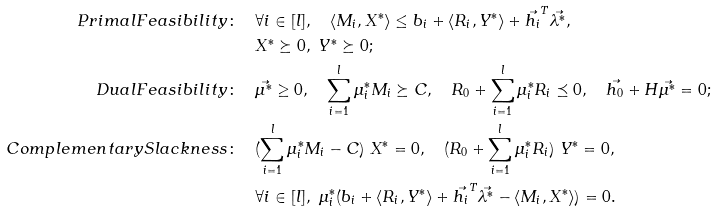<formula> <loc_0><loc_0><loc_500><loc_500>P r i m a l F e a s i b i l i t y \colon & \quad \forall i \in [ l ] , \quad \langle M _ { i } , X ^ { * } \rangle \leq b _ { i } + \langle R _ { i } , Y ^ { * } \rangle + \vec { h _ { i } } ^ { T } \vec { \lambda ^ { * } } , \\ & \quad X ^ { * } \succeq 0 , \ Y ^ { * } \succeq 0 ; \\ D u a l F e a s i b i l i t y \colon & \quad \vec { \mu ^ { * } } \geq 0 , \quad \sum _ { i = 1 } ^ { l } \mu _ { i } ^ { * } M _ { i } \succeq C , \quad R _ { 0 } + \sum _ { i = 1 } ^ { l } \mu _ { i } ^ { * } R _ { i } \preceq 0 , \quad \vec { h _ { 0 } } + H \vec { \mu ^ { * } } = 0 ; \\ C o m p l e m e n t a r y S l a c k n e s s \colon & \quad ( \sum _ { i = 1 } ^ { l } \mu _ { i } ^ { * } M _ { i } - C ) \ X ^ { * } = 0 , \quad ( R _ { 0 } + \sum _ { i = 1 } ^ { l } \mu _ { i } ^ { * } R _ { i } ) \ Y ^ { * } = 0 , \\ & \quad \forall i \in [ l ] , \ \mu _ { i } ^ { * } ( b _ { i } + \langle R _ { i } , Y ^ { * } \rangle + \vec { h _ { i } } ^ { T } \vec { \lambda ^ { * } } - \langle M _ { i } , X ^ { * } \rangle ) = 0 .</formula> 